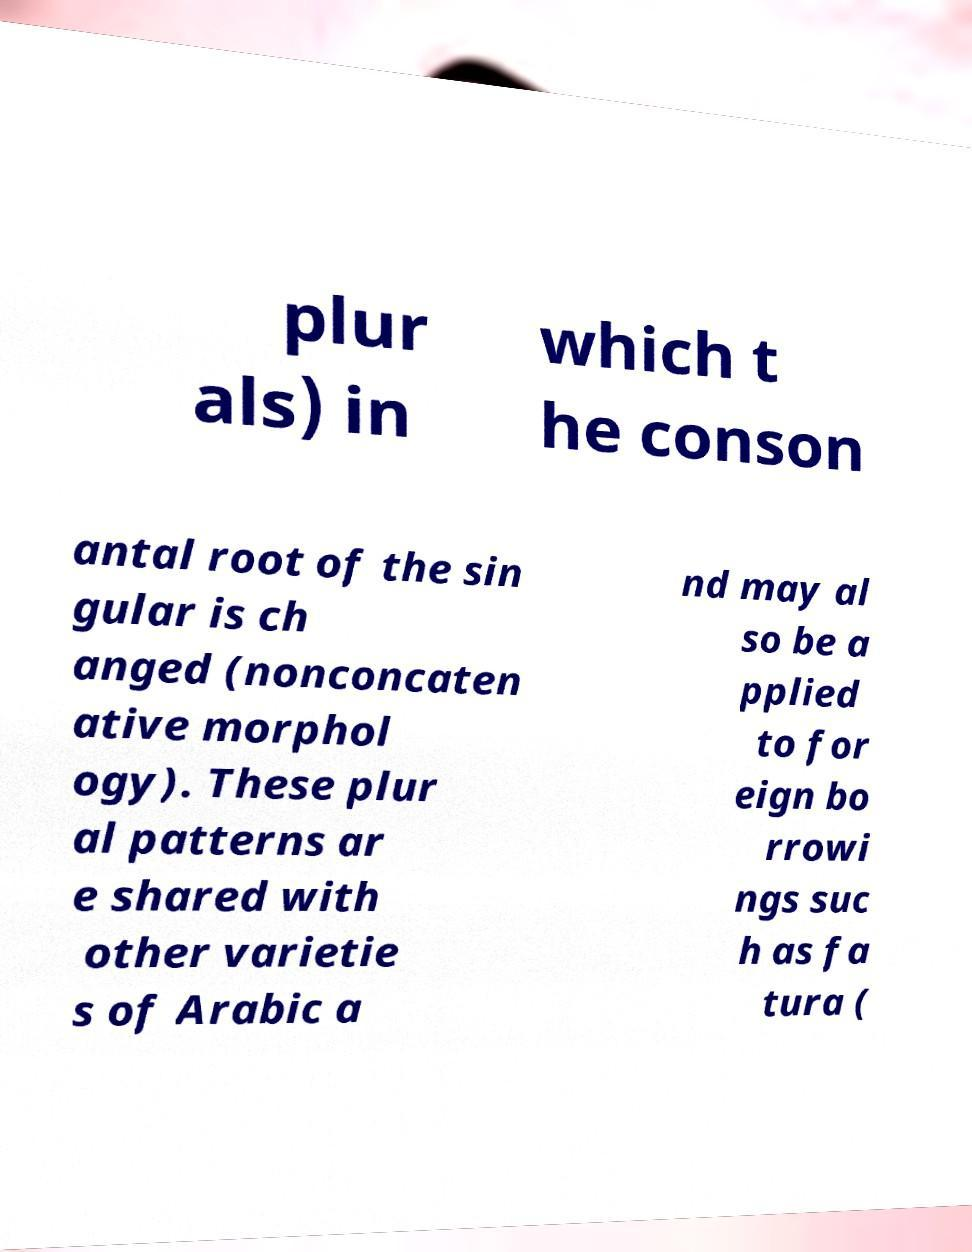Can you accurately transcribe the text from the provided image for me? plur als) in which t he conson antal root of the sin gular is ch anged (nonconcaten ative morphol ogy). These plur al patterns ar e shared with other varietie s of Arabic a nd may al so be a pplied to for eign bo rrowi ngs suc h as fa tura ( 